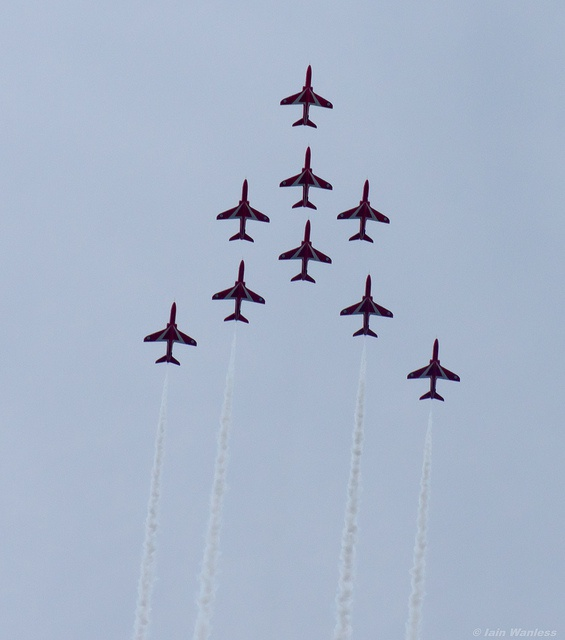Describe the objects in this image and their specific colors. I can see airplane in lightgray, black, darkgray, purple, and lightblue tones, airplane in lightgray, navy, darkgray, and gray tones, airplane in lightgray, purple, gray, and navy tones, airplane in lavender, black, gray, and purple tones, and airplane in lavender, purple, gray, and navy tones in this image. 